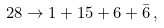<formula> <loc_0><loc_0><loc_500><loc_500>2 8 \rightarrow 1 + 1 5 + 6 + \bar { 6 } \, ,</formula> 